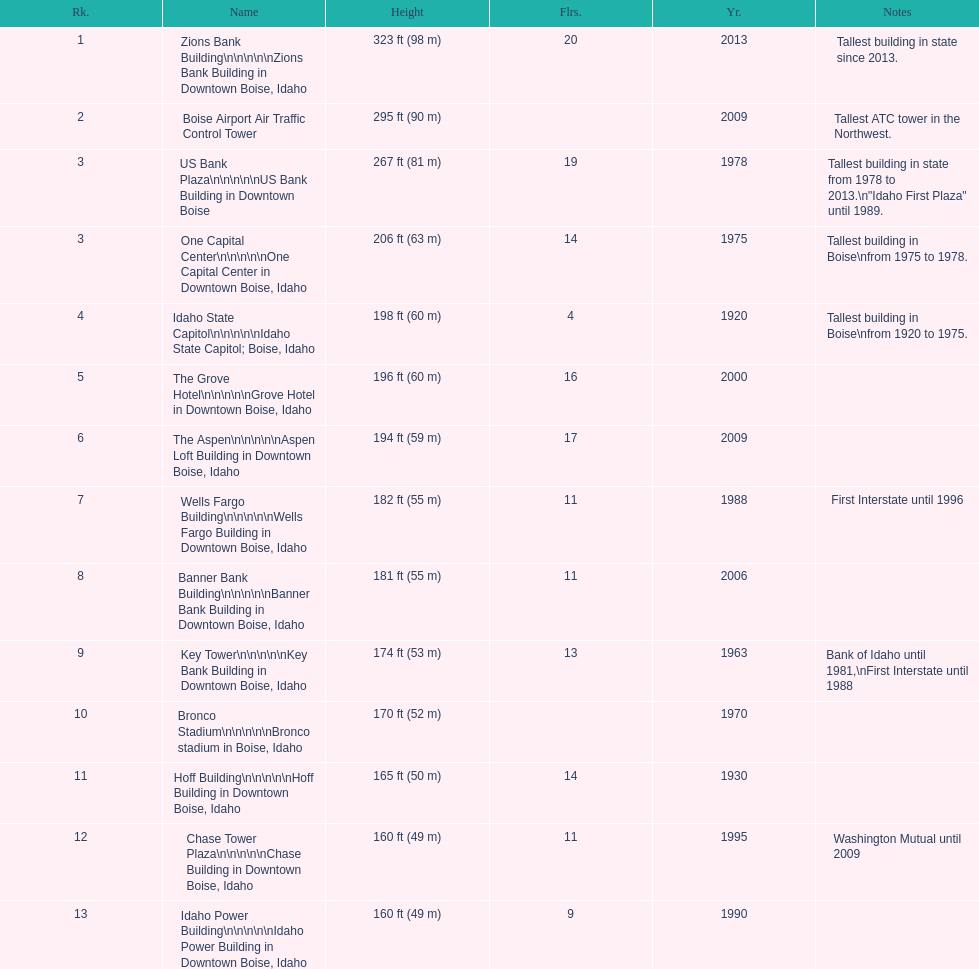Would you mind parsing the complete table? {'header': ['Rk.', 'Name', 'Height', 'Flrs.', 'Yr.', 'Notes'], 'rows': [['1', 'Zions Bank Building\\n\\n\\n\\n\\nZions Bank Building in Downtown Boise, Idaho', '323\xa0ft (98\xa0m)', '20', '2013', 'Tallest building in state since 2013.'], ['2', 'Boise Airport Air Traffic Control Tower', '295\xa0ft (90\xa0m)', '', '2009', 'Tallest ATC tower in the Northwest.'], ['3', 'US Bank Plaza\\n\\n\\n\\n\\nUS Bank Building in Downtown Boise', '267\xa0ft (81\xa0m)', '19', '1978', 'Tallest building in state from 1978 to 2013.\\n"Idaho First Plaza" until 1989.'], ['3', 'One Capital Center\\n\\n\\n\\n\\nOne Capital Center in Downtown Boise, Idaho', '206\xa0ft (63\xa0m)', '14', '1975', 'Tallest building in Boise\\nfrom 1975 to 1978.'], ['4', 'Idaho State Capitol\\n\\n\\n\\n\\nIdaho State Capitol; Boise, Idaho', '198\xa0ft (60\xa0m)', '4', '1920', 'Tallest building in Boise\\nfrom 1920 to 1975.'], ['5', 'The Grove Hotel\\n\\n\\n\\n\\nGrove Hotel in Downtown Boise, Idaho', '196\xa0ft (60\xa0m)', '16', '2000', ''], ['6', 'The Aspen\\n\\n\\n\\n\\nAspen Loft Building in Downtown Boise, Idaho', '194\xa0ft (59\xa0m)', '17', '2009', ''], ['7', 'Wells Fargo Building\\n\\n\\n\\n\\nWells Fargo Building in Downtown Boise, Idaho', '182\xa0ft (55\xa0m)', '11', '1988', 'First Interstate until 1996'], ['8', 'Banner Bank Building\\n\\n\\n\\n\\nBanner Bank Building in Downtown Boise, Idaho', '181\xa0ft (55\xa0m)', '11', '2006', ''], ['9', 'Key Tower\\n\\n\\n\\n\\nKey Bank Building in Downtown Boise, Idaho', '174\xa0ft (53\xa0m)', '13', '1963', 'Bank of Idaho until 1981,\\nFirst Interstate until 1988'], ['10', 'Bronco Stadium\\n\\n\\n\\n\\nBronco stadium in Boise, Idaho', '170\xa0ft (52\xa0m)', '', '1970', ''], ['11', 'Hoff Building\\n\\n\\n\\n\\nHoff Building in Downtown Boise, Idaho', '165\xa0ft (50\xa0m)', '14', '1930', ''], ['12', 'Chase Tower Plaza\\n\\n\\n\\n\\nChase Building in Downtown Boise, Idaho', '160\xa0ft (49\xa0m)', '11', '1995', 'Washington Mutual until 2009'], ['13', 'Idaho Power Building\\n\\n\\n\\n\\nIdaho Power Building in Downtown Boise, Idaho', '160\xa0ft (49\xa0m)', '9', '1990', '']]} What is the name of the last building on this chart? Idaho Power Building. 